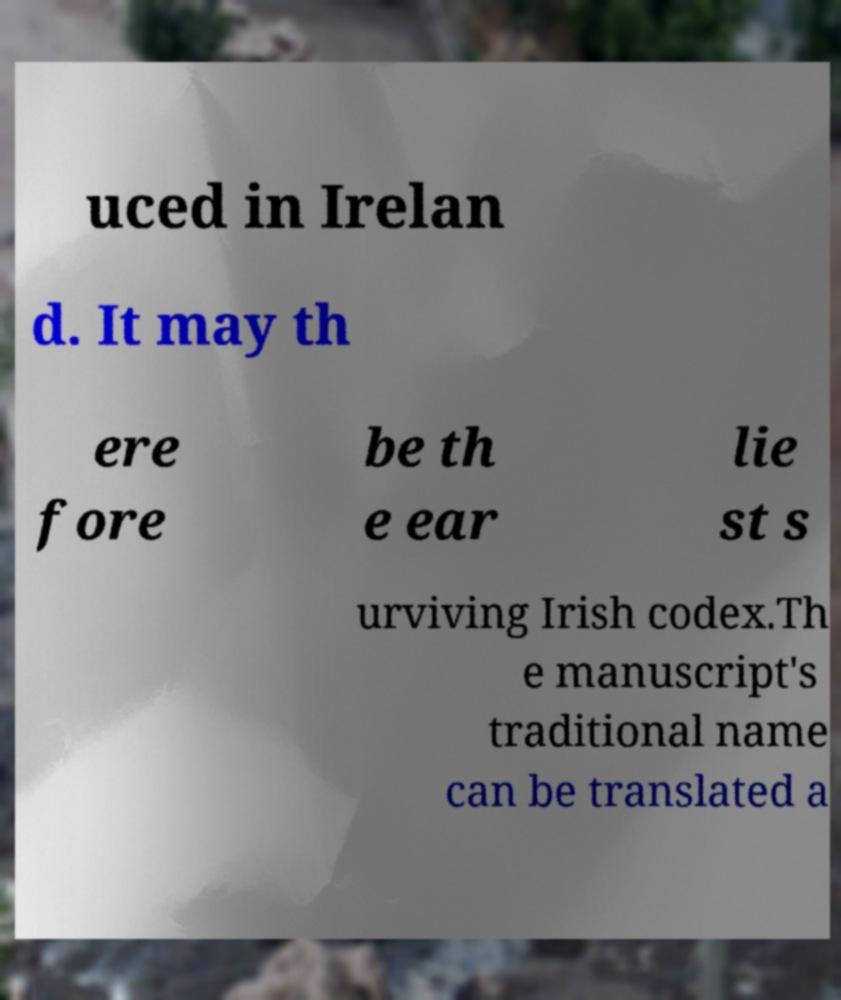I need the written content from this picture converted into text. Can you do that? uced in Irelan d. It may th ere fore be th e ear lie st s urviving Irish codex.Th e manuscript's traditional name can be translated a 